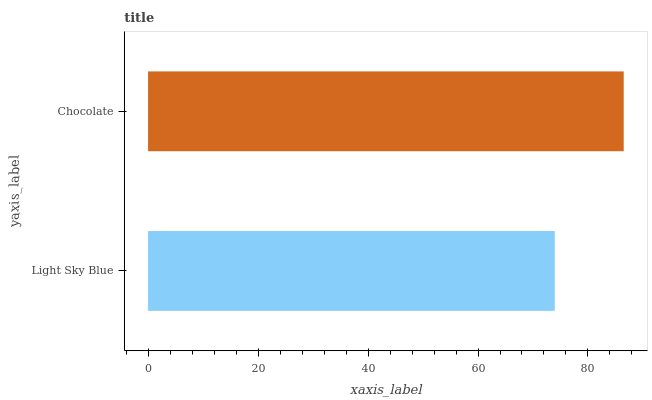Is Light Sky Blue the minimum?
Answer yes or no. Yes. Is Chocolate the maximum?
Answer yes or no. Yes. Is Chocolate the minimum?
Answer yes or no. No. Is Chocolate greater than Light Sky Blue?
Answer yes or no. Yes. Is Light Sky Blue less than Chocolate?
Answer yes or no. Yes. Is Light Sky Blue greater than Chocolate?
Answer yes or no. No. Is Chocolate less than Light Sky Blue?
Answer yes or no. No. Is Chocolate the high median?
Answer yes or no. Yes. Is Light Sky Blue the low median?
Answer yes or no. Yes. Is Light Sky Blue the high median?
Answer yes or no. No. Is Chocolate the low median?
Answer yes or no. No. 